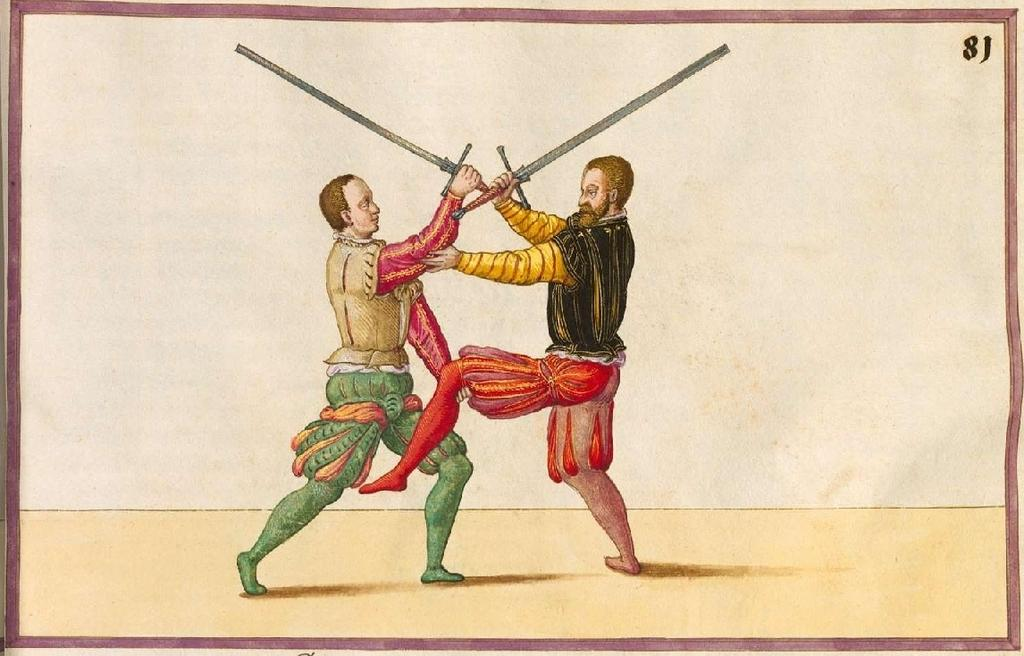What type of image is being described? The image is a poster. How many people are depicted in the poster? There are two men in the poster. What are the men holding in their hands? The men are holding swords in their hands. Is there a volcano erupting in the background of the poster? No, there is no volcano present in the poster. What invention is being showcased by the men in the poster? There is no invention being showcased in the poster; the men are simply holding swords. 